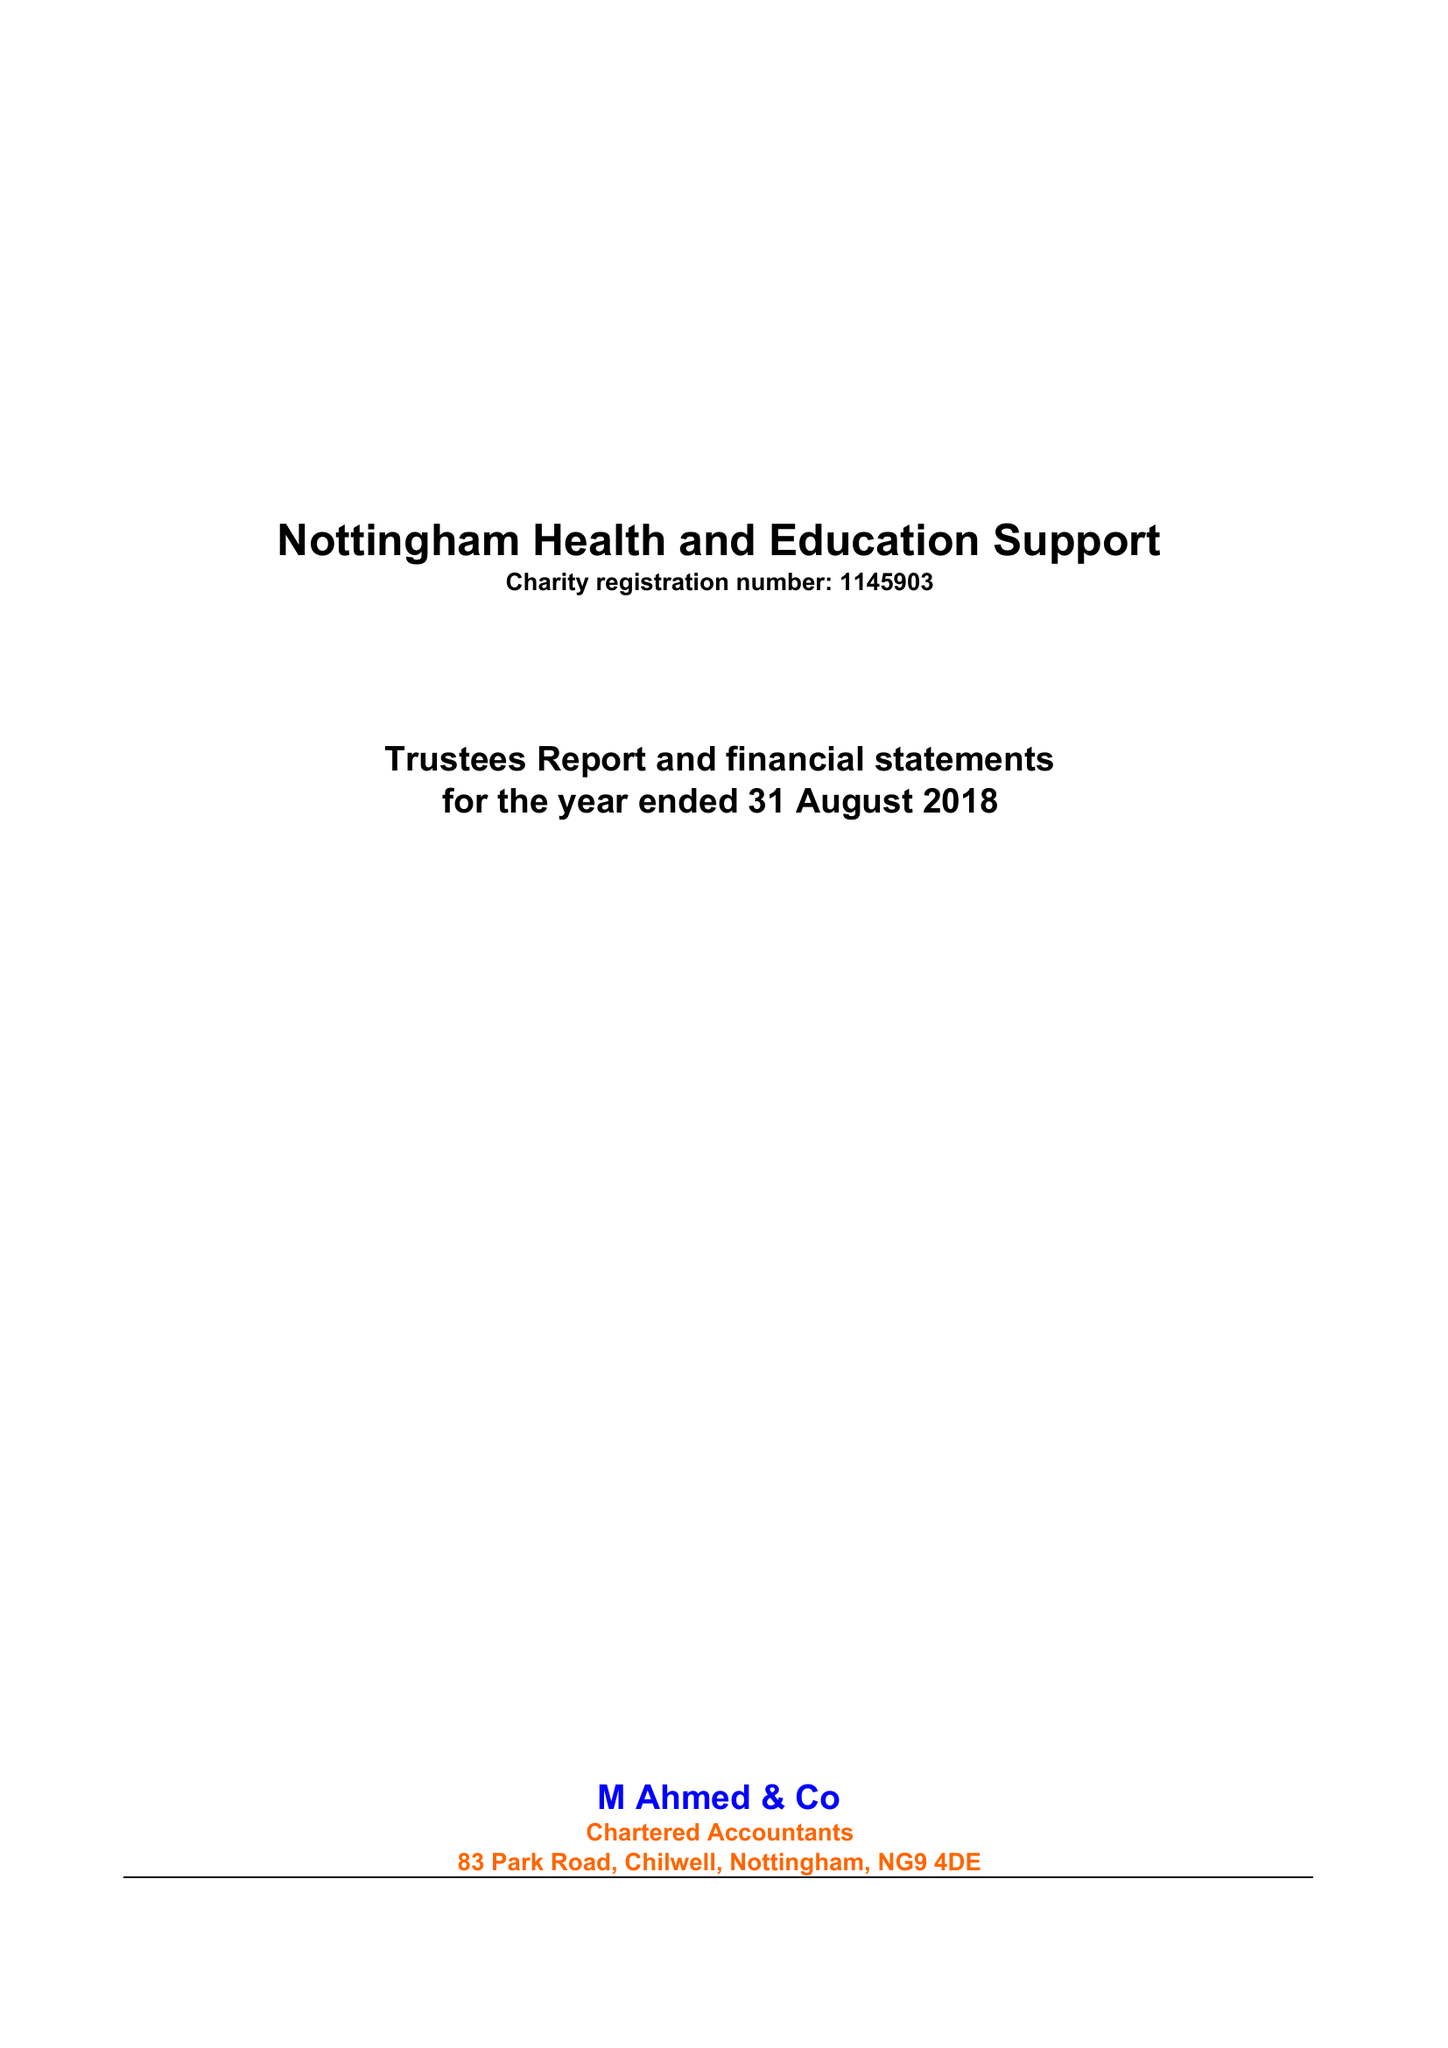What is the value for the address__post_town?
Answer the question using a single word or phrase. NOTTINGHAM 